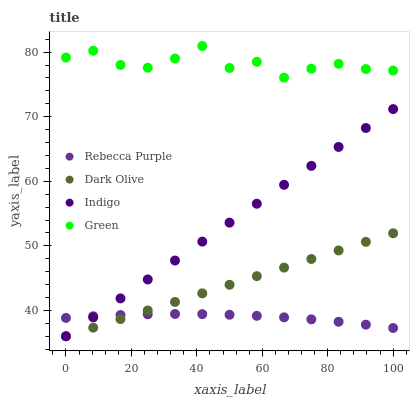Does Rebecca Purple have the minimum area under the curve?
Answer yes or no. Yes. Does Green have the maximum area under the curve?
Answer yes or no. Yes. Does Dark Olive have the minimum area under the curve?
Answer yes or no. No. Does Dark Olive have the maximum area under the curve?
Answer yes or no. No. Is Dark Olive the smoothest?
Answer yes or no. Yes. Is Green the roughest?
Answer yes or no. Yes. Is Indigo the smoothest?
Answer yes or no. No. Is Indigo the roughest?
Answer yes or no. No. Does Dark Olive have the lowest value?
Answer yes or no. Yes. Does Rebecca Purple have the lowest value?
Answer yes or no. No. Does Green have the highest value?
Answer yes or no. Yes. Does Dark Olive have the highest value?
Answer yes or no. No. Is Dark Olive less than Green?
Answer yes or no. Yes. Is Green greater than Rebecca Purple?
Answer yes or no. Yes. Does Dark Olive intersect Rebecca Purple?
Answer yes or no. Yes. Is Dark Olive less than Rebecca Purple?
Answer yes or no. No. Is Dark Olive greater than Rebecca Purple?
Answer yes or no. No. Does Dark Olive intersect Green?
Answer yes or no. No. 